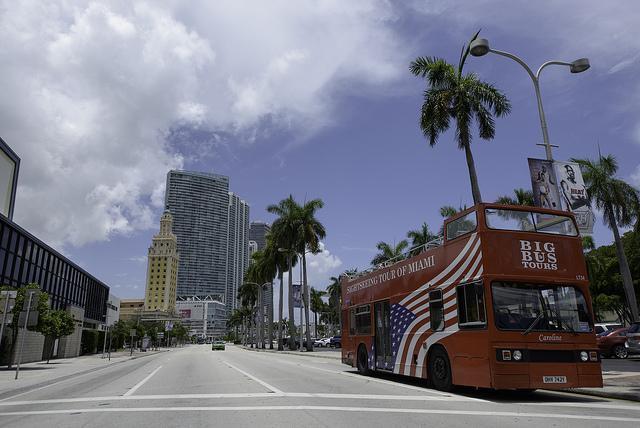How many buses do you see?
Give a very brief answer. 1. 